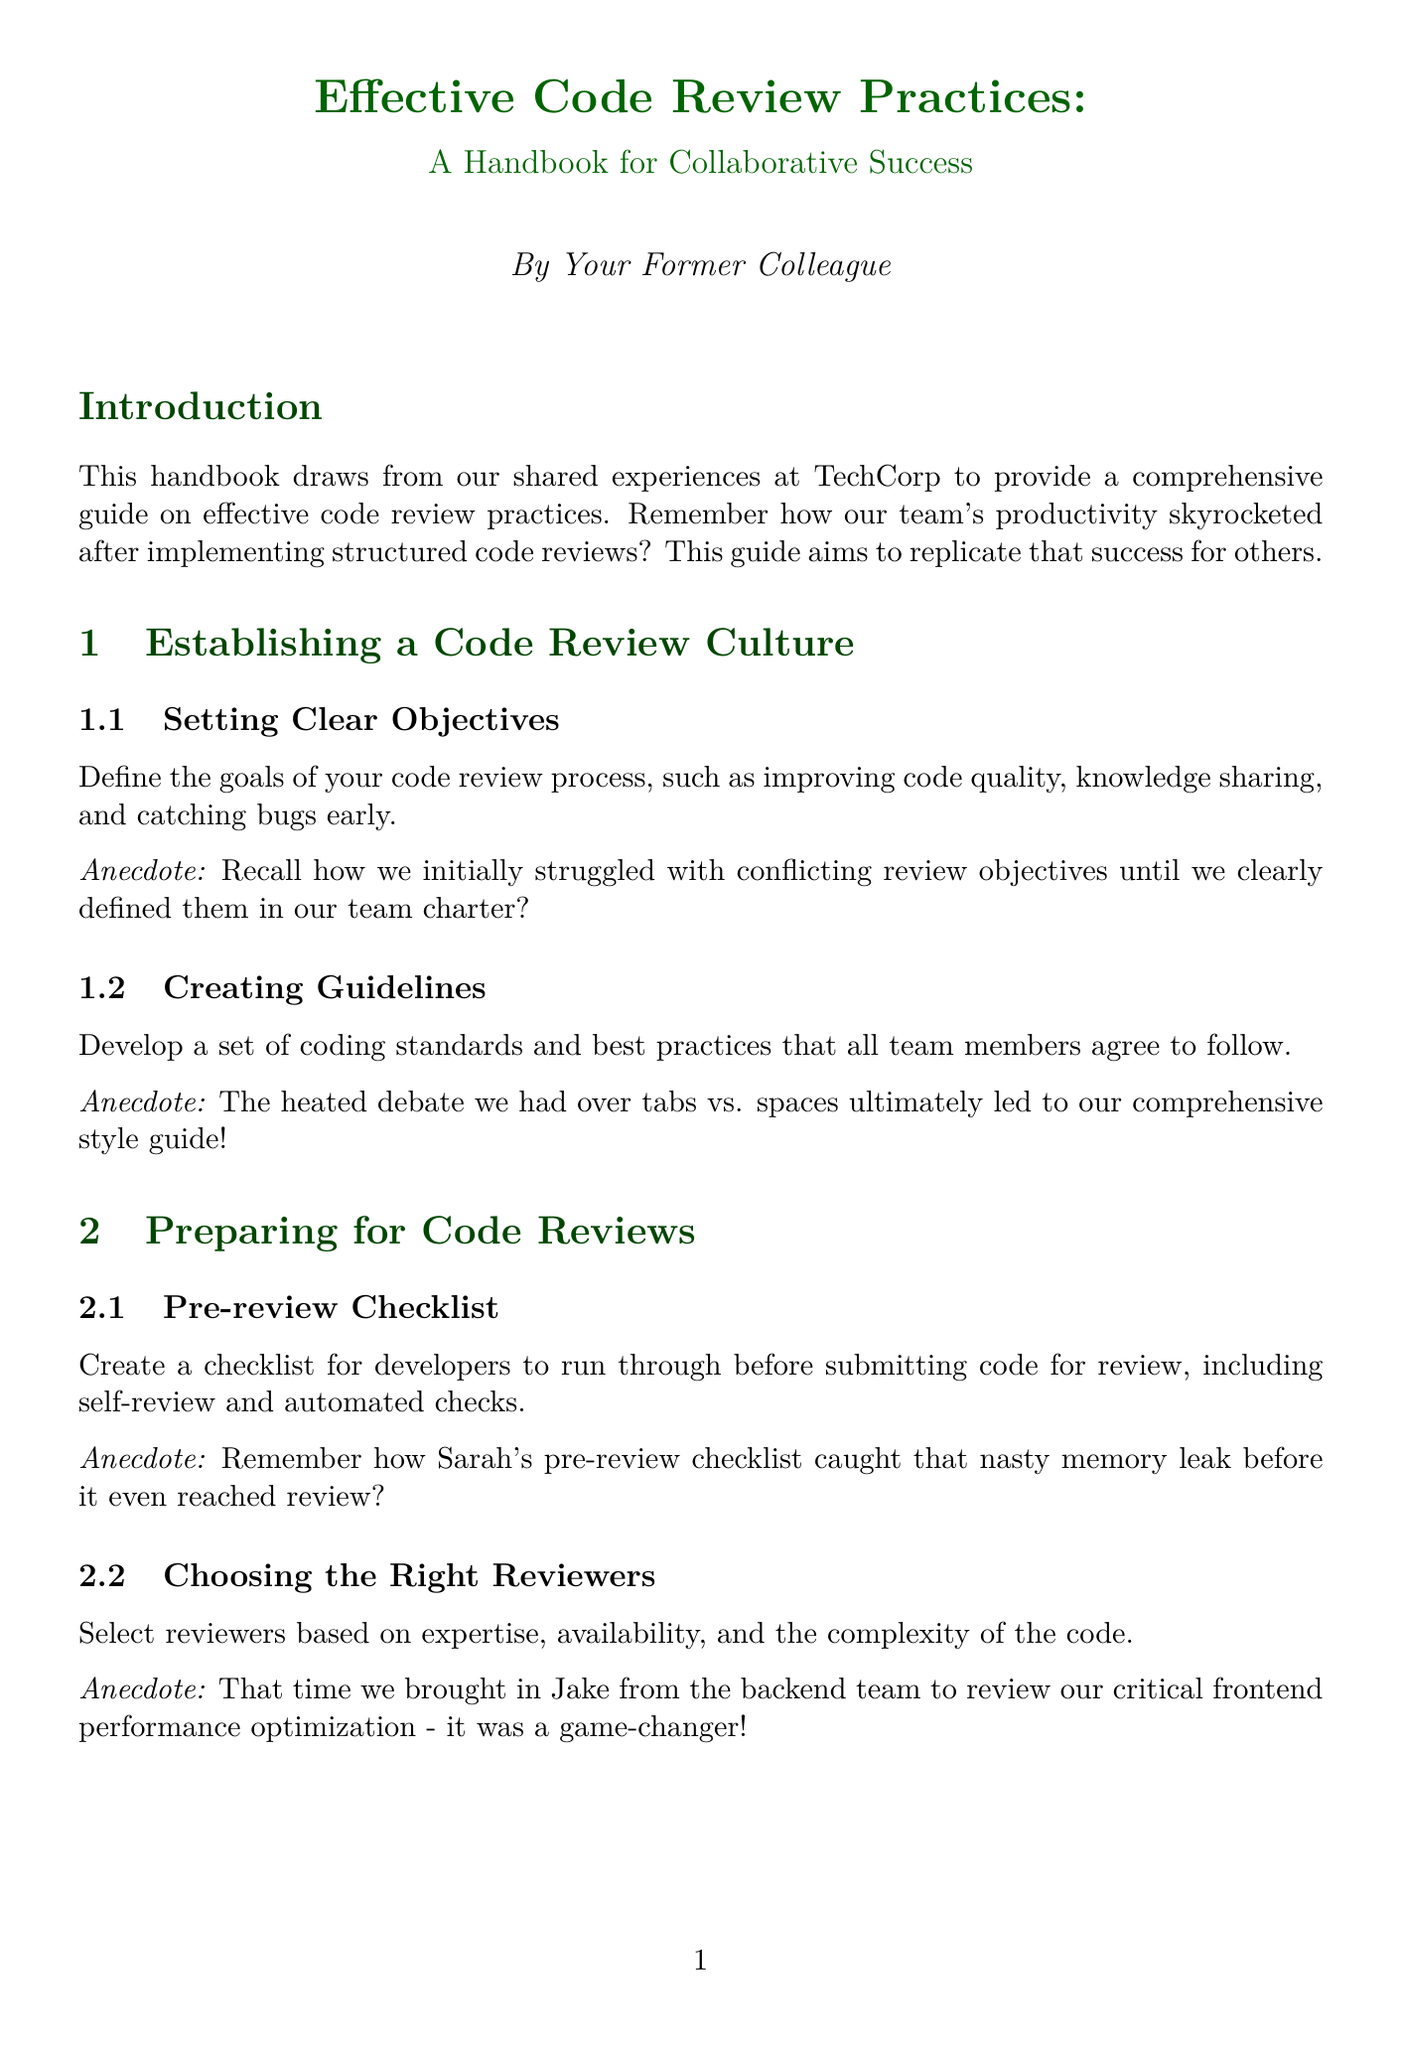What is the title of the handbook? The title is mentioned in the header of the document as the main focus, introducing the reader to the subject.
Answer: Effective Code Review Practices: A Handbook for Collaborative Success How many chapters are in the handbook? The chapters are outlined clearly with titles indicating major sections of the handbook.
Answer: Six What is one key objective for establishing a code review culture? Objectives are defined in the first chapter, highlighting specific goals needed for successful code reviews.
Answer: Improving code quality Who caught the memory leak before it reached review? Anecdotes provide personal insights and highlight pivotal moments in the code review process shared within the team.
Answer: Sarah Which tool is suggested for static analysis? Tools are listed to automate and improve the code review process, providing specific examples for guidance.
Answer: SonarQube What metric was surprisingly calculated during the process? Metrics discussed show the importance of measuring the effectiveness of code reviews.
Answer: Defects prevented What is essential for constructive feedback? The document emphasizes specific methods for delivering helpful critiques within a review.
Answer: Specific, actionable feedback What type of meetings helped improve team dynamics? Certain practices were introduced to facilitate better communication and understanding within the team.
Answer: Code review retro meetings Who was brought in for critical frontend performance optimization? This reference exemplifies the practice of selecting appropriate reviewers with relevant expertise for better outcomes.
Answer: Jake 